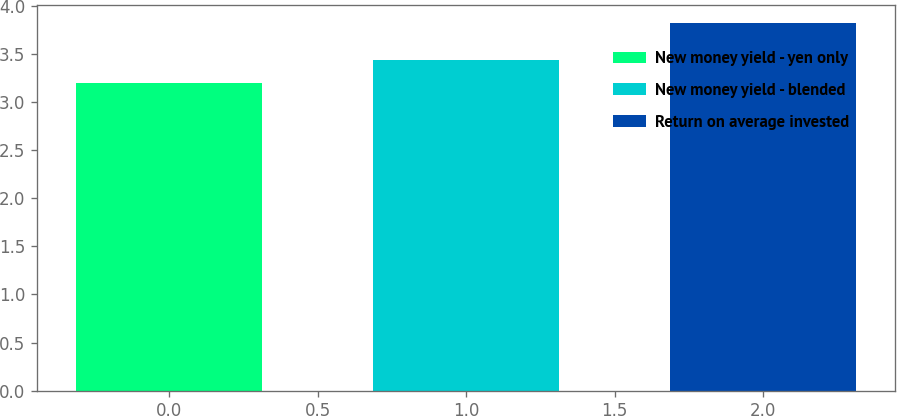<chart> <loc_0><loc_0><loc_500><loc_500><bar_chart><fcel>New money yield - yen only<fcel>New money yield - blended<fcel>Return on average invested<nl><fcel>3.2<fcel>3.43<fcel>3.82<nl></chart> 